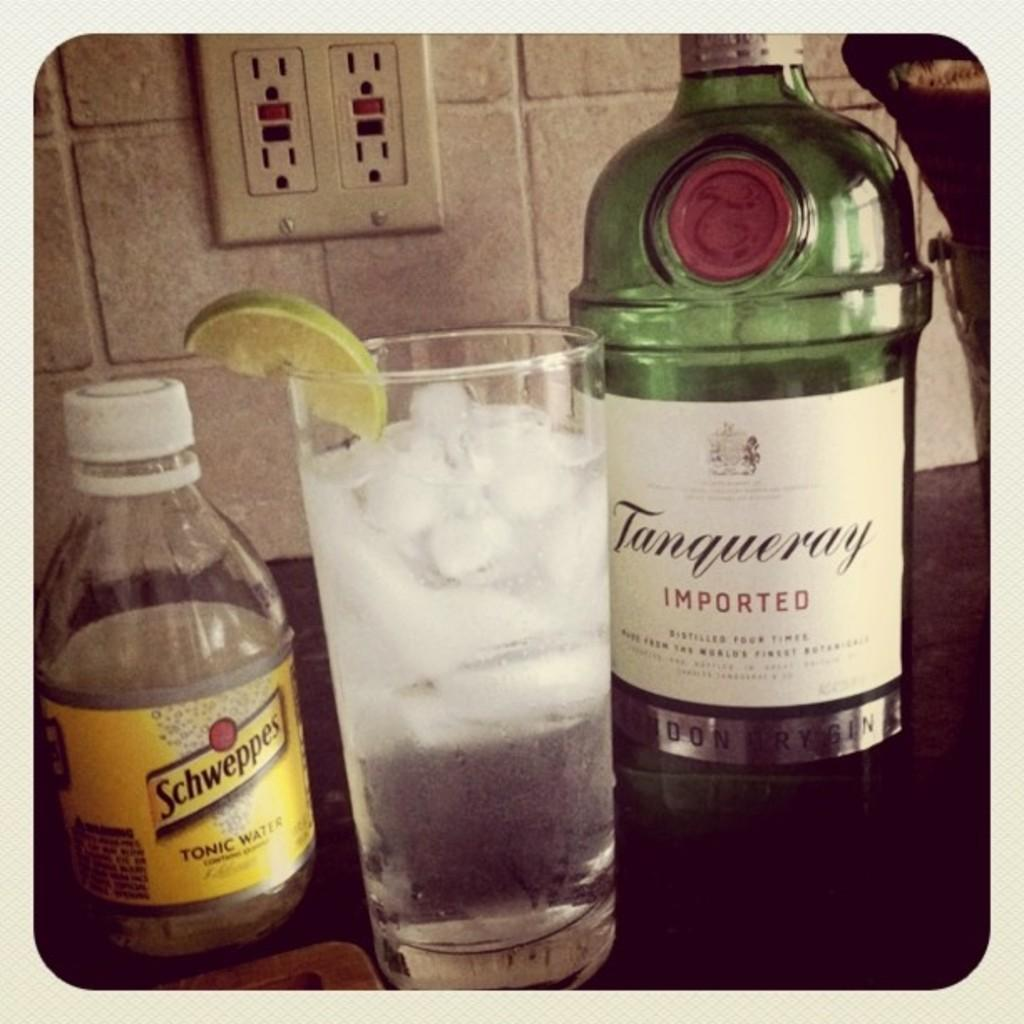<image>
Present a compact description of the photo's key features. Schweppers tonic water is am option to mix into a drink. 